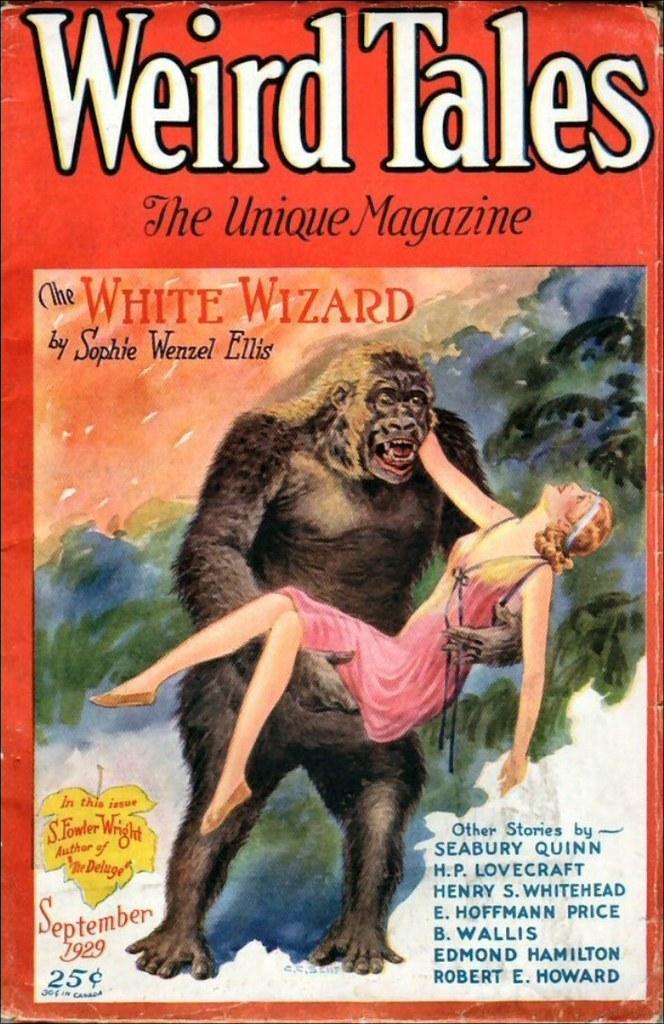Can you describe this image briefly? In this image we can see a poster. On this poster we can see picture of an ape holding a woman and something is written on it. 